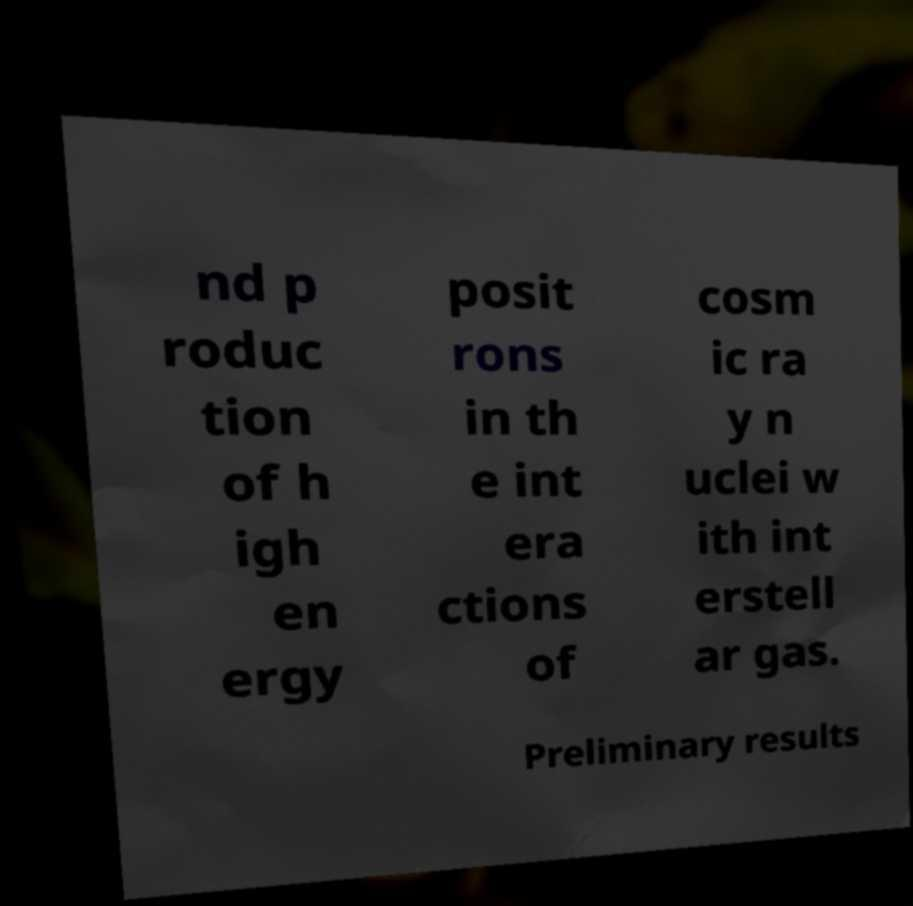Please identify and transcribe the text found in this image. nd p roduc tion of h igh en ergy posit rons in th e int era ctions of cosm ic ra y n uclei w ith int erstell ar gas. Preliminary results 